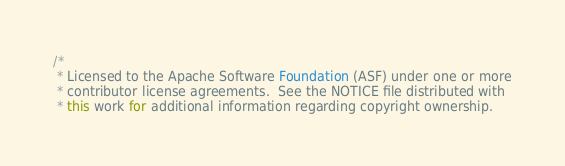<code> <loc_0><loc_0><loc_500><loc_500><_Java_>/*
 * Licensed to the Apache Software Foundation (ASF) under one or more
 * contributor license agreements.  See the NOTICE file distributed with
 * this work for additional information regarding copyright ownership.</code> 